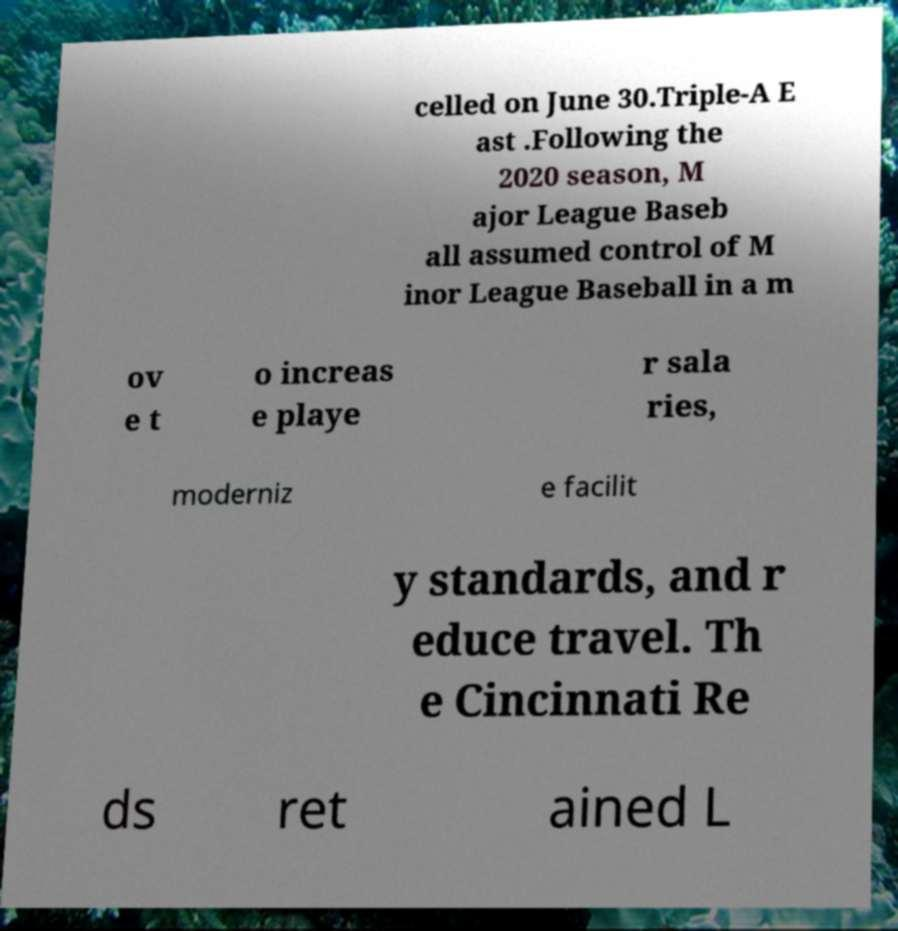Please identify and transcribe the text found in this image. celled on June 30.Triple-A E ast .Following the 2020 season, M ajor League Baseb all assumed control of M inor League Baseball in a m ov e t o increas e playe r sala ries, moderniz e facilit y standards, and r educe travel. Th e Cincinnati Re ds ret ained L 